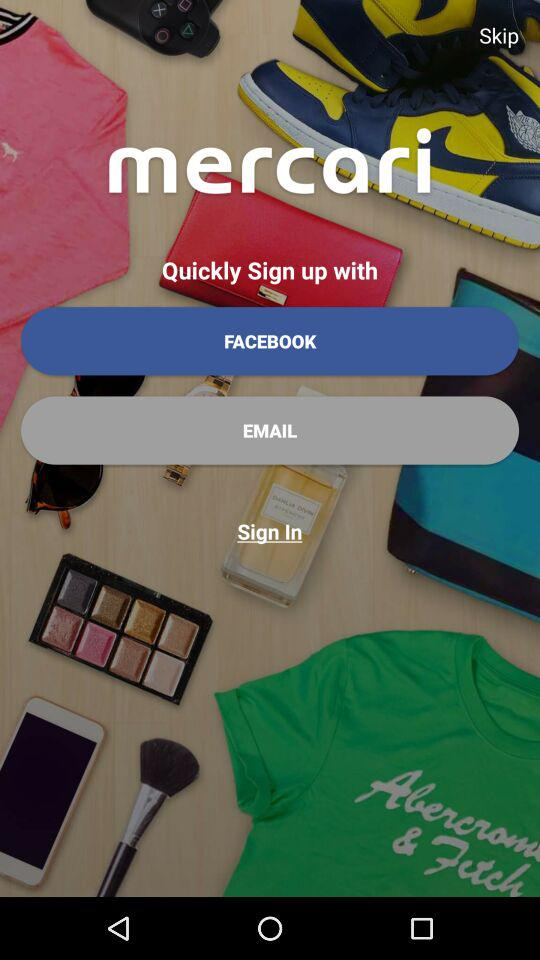What is the name of the application? The name of the application is "mercari". 